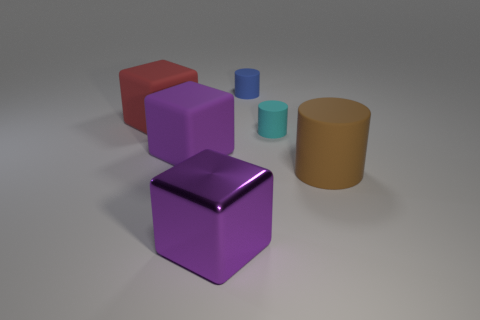Subtract all cyan cylinders. Subtract all green cubes. How many cylinders are left? 2 Subtract all red cubes. How many yellow cylinders are left? 0 Add 2 purples. How many big reds exist? 0 Subtract all red objects. Subtract all large purple matte objects. How many objects are left? 4 Add 6 large purple rubber blocks. How many large purple rubber blocks are left? 7 Add 4 small yellow cylinders. How many small yellow cylinders exist? 4 Add 4 big cylinders. How many objects exist? 10 Subtract all red cubes. How many cubes are left? 2 Subtract all large matte cylinders. How many cylinders are left? 2 Subtract 0 gray spheres. How many objects are left? 6 